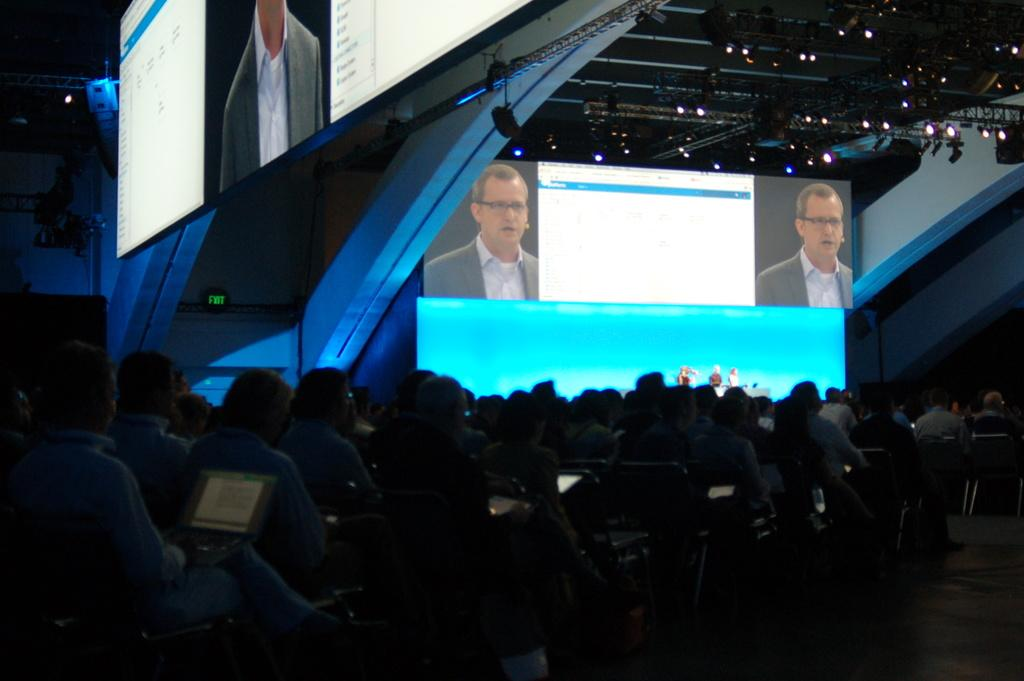What is happening at the bottom of the image? There are many people sitting at the bottom of the image. Can you describe the man on the left side of the image? There is a man sitting on a chair on the left side of the image. What can be seen at the top of the image? At the top of the image, there are people, screens, lights, a stage, and a wall. What might the screens be used for in the image? The screens at the top of the image might be used for displaying information or visuals. What is the purpose of the stage in the image? The stage in the top part of the image might be used for performances or presentations. Can you tell me how many flowers are on the stage in the image? There are no flowers present on the stage in the image. What type of exercise is the man on the left side of the image doing? The man on the left side of the image is sitting on a chair, not exercising. 